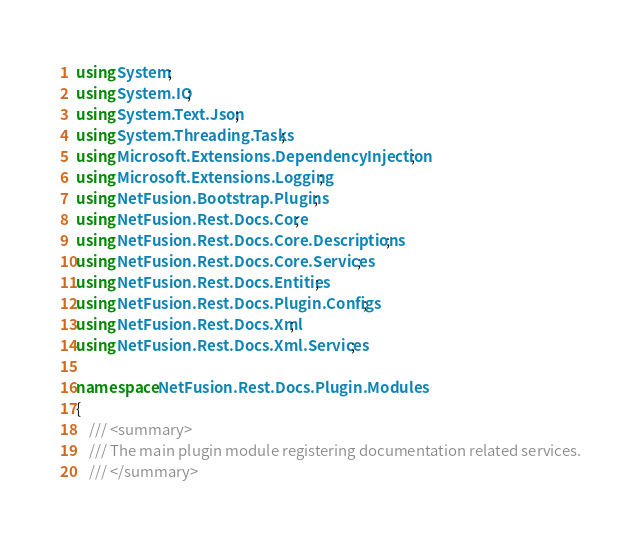<code> <loc_0><loc_0><loc_500><loc_500><_C#_>using System;
using System.IO;
using System.Text.Json;
using System.Threading.Tasks;
using Microsoft.Extensions.DependencyInjection;
using Microsoft.Extensions.Logging;
using NetFusion.Bootstrap.Plugins;
using NetFusion.Rest.Docs.Core;
using NetFusion.Rest.Docs.Core.Descriptions;
using NetFusion.Rest.Docs.Core.Services;
using NetFusion.Rest.Docs.Entities;
using NetFusion.Rest.Docs.Plugin.Configs;
using NetFusion.Rest.Docs.Xml;
using NetFusion.Rest.Docs.Xml.Services;

namespace NetFusion.Rest.Docs.Plugin.Modules
{
    /// <summary>
    /// The main plugin module registering documentation related services.
    /// </summary></code> 